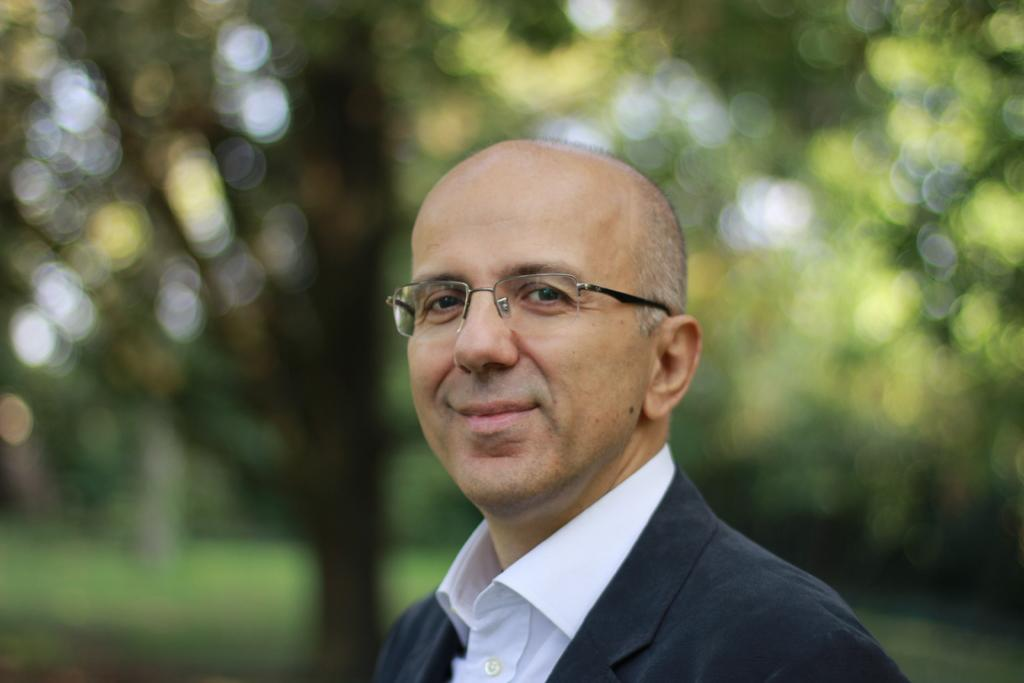Who is present in the image? There is a man in the image. What is the man wearing? The man is wearing glasses. What is the man doing in the image? The man is looking at something and smiling. Can you describe the background of the image? The background of the image has a blurred view. What type of natural environment can be seen in the image? There is greenery visible in the image. What type of bell can be heard ringing in the image? There is no bell present or audible in the image. Can you see any planes taking off or landing at the airport in the image? There is no airport or planes visible in the image. Is there a lake visible in the image? There is no lake visible in the image; only greenery is mentioned. 